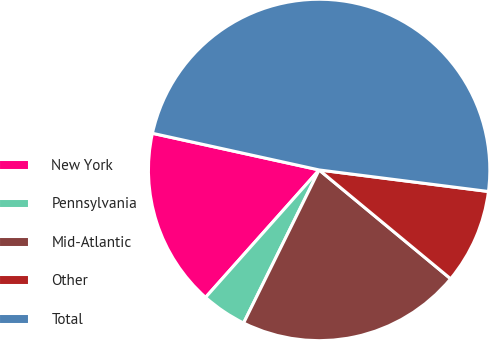<chart> <loc_0><loc_0><loc_500><loc_500><pie_chart><fcel>New York<fcel>Pennsylvania<fcel>Mid-Atlantic<fcel>Other<fcel>Total<nl><fcel>16.86%<fcel>4.29%<fcel>21.29%<fcel>8.99%<fcel>48.57%<nl></chart> 